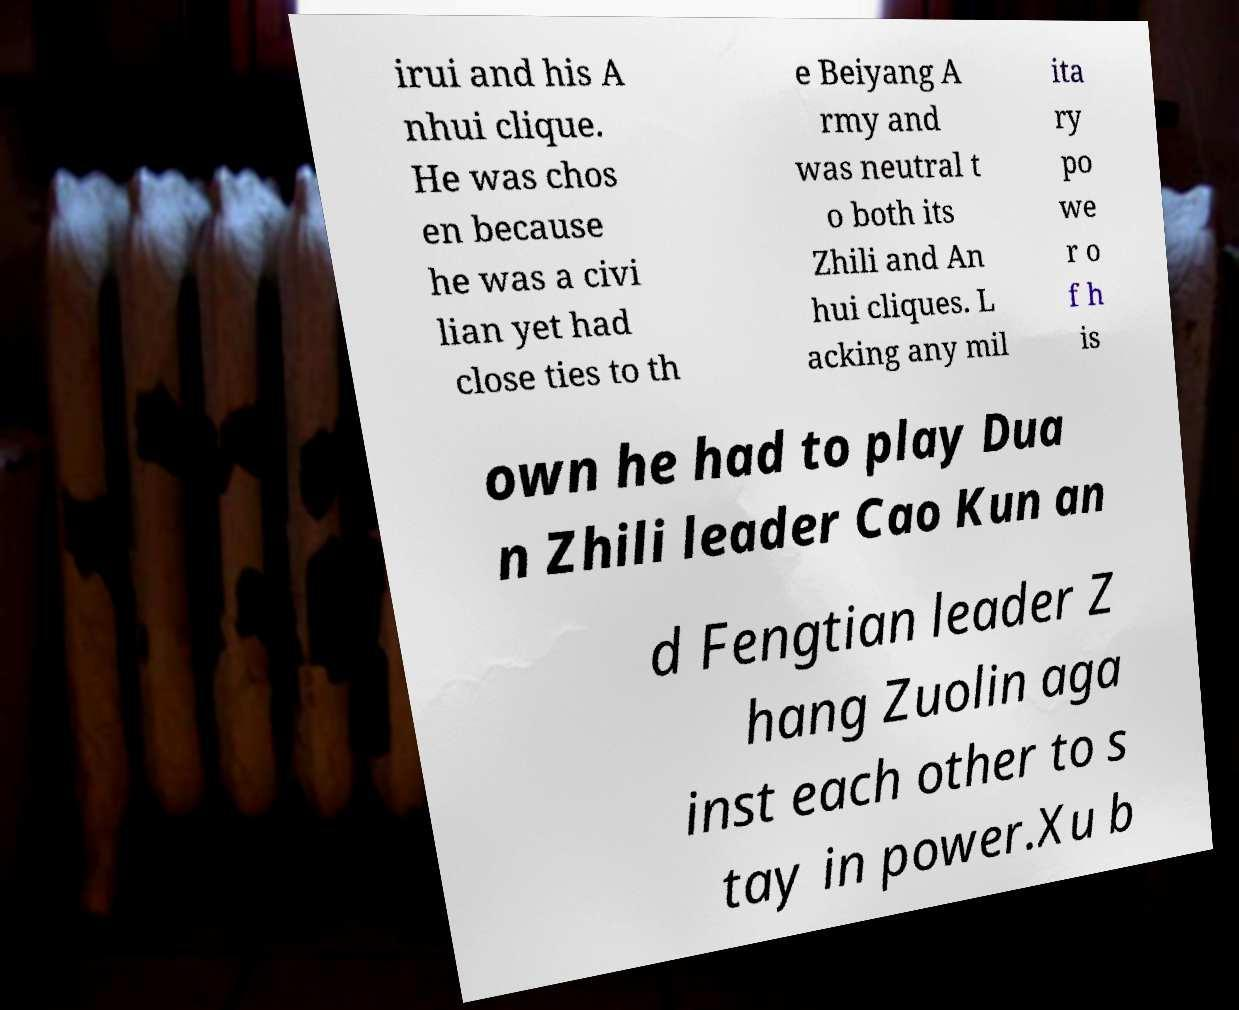There's text embedded in this image that I need extracted. Can you transcribe it verbatim? irui and his A nhui clique. He was chos en because he was a civi lian yet had close ties to th e Beiyang A rmy and was neutral t o both its Zhili and An hui cliques. L acking any mil ita ry po we r o f h is own he had to play Dua n Zhili leader Cao Kun an d Fengtian leader Z hang Zuolin aga inst each other to s tay in power.Xu b 